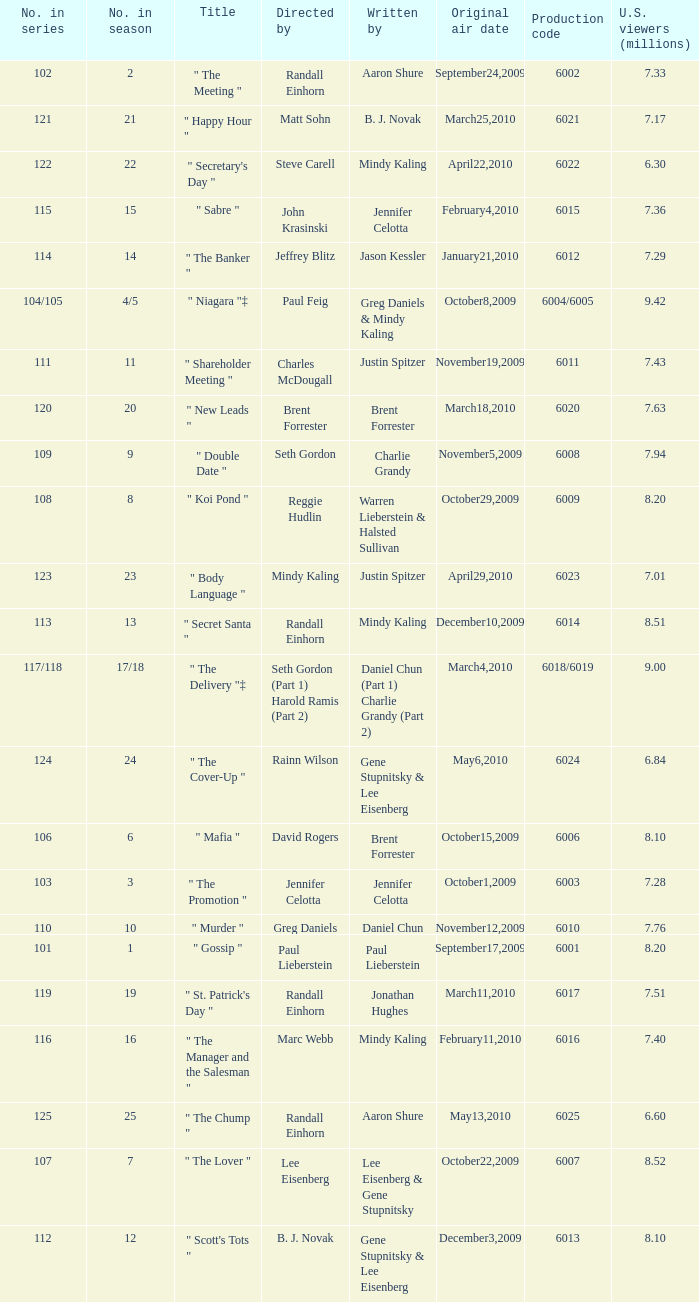Name the production code by paul lieberstein 6001.0. 